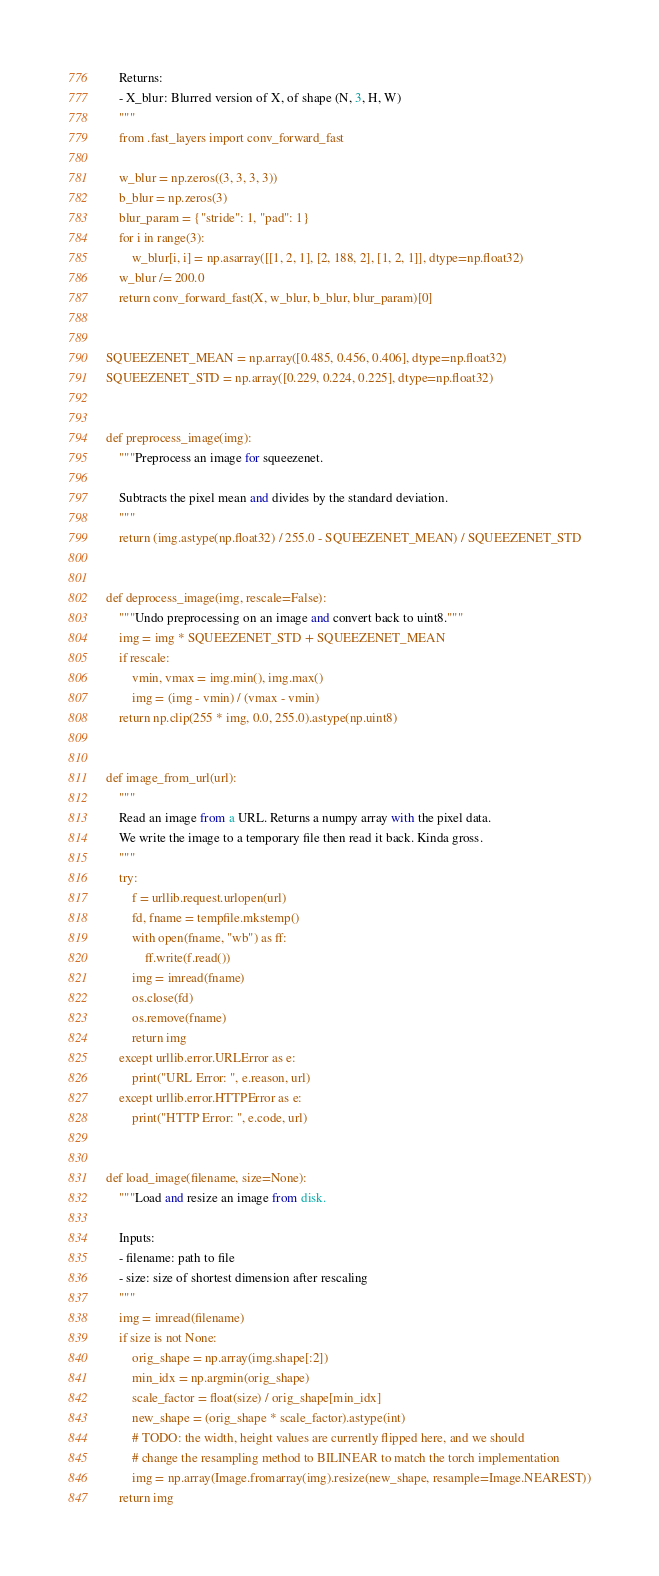Convert code to text. <code><loc_0><loc_0><loc_500><loc_500><_Python_>
    Returns:
    - X_blur: Blurred version of X, of shape (N, 3, H, W)
    """
    from .fast_layers import conv_forward_fast

    w_blur = np.zeros((3, 3, 3, 3))
    b_blur = np.zeros(3)
    blur_param = {"stride": 1, "pad": 1}
    for i in range(3):
        w_blur[i, i] = np.asarray([[1, 2, 1], [2, 188, 2], [1, 2, 1]], dtype=np.float32)
    w_blur /= 200.0
    return conv_forward_fast(X, w_blur, b_blur, blur_param)[0]


SQUEEZENET_MEAN = np.array([0.485, 0.456, 0.406], dtype=np.float32)
SQUEEZENET_STD = np.array([0.229, 0.224, 0.225], dtype=np.float32)


def preprocess_image(img):
    """Preprocess an image for squeezenet.

    Subtracts the pixel mean and divides by the standard deviation.
    """
    return (img.astype(np.float32) / 255.0 - SQUEEZENET_MEAN) / SQUEEZENET_STD


def deprocess_image(img, rescale=False):
    """Undo preprocessing on an image and convert back to uint8."""
    img = img * SQUEEZENET_STD + SQUEEZENET_MEAN
    if rescale:
        vmin, vmax = img.min(), img.max()
        img = (img - vmin) / (vmax - vmin)
    return np.clip(255 * img, 0.0, 255.0).astype(np.uint8)


def image_from_url(url):
    """
    Read an image from a URL. Returns a numpy array with the pixel data.
    We write the image to a temporary file then read it back. Kinda gross.
    """
    try:
        f = urllib.request.urlopen(url)
        fd, fname = tempfile.mkstemp()
        with open(fname, "wb") as ff:
            ff.write(f.read())
        img = imread(fname)
        os.close(fd)
        os.remove(fname)
        return img
    except urllib.error.URLError as e:
        print("URL Error: ", e.reason, url)
    except urllib.error.HTTPError as e:
        print("HTTP Error: ", e.code, url)


def load_image(filename, size=None):
    """Load and resize an image from disk.

    Inputs:
    - filename: path to file
    - size: size of shortest dimension after rescaling
    """
    img = imread(filename)
    if size is not None:
        orig_shape = np.array(img.shape[:2])
        min_idx = np.argmin(orig_shape)
        scale_factor = float(size) / orig_shape[min_idx]
        new_shape = (orig_shape * scale_factor).astype(int)
        # TODO: the width, height values are currently flipped here, and we should
        # change the resampling method to BILINEAR to match the torch implementation
        img = np.array(Image.fromarray(img).resize(new_shape, resample=Image.NEAREST))
    return img
</code> 